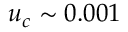Convert formula to latex. <formula><loc_0><loc_0><loc_500><loc_500>u _ { c } \sim 0 . 0 0 1</formula> 